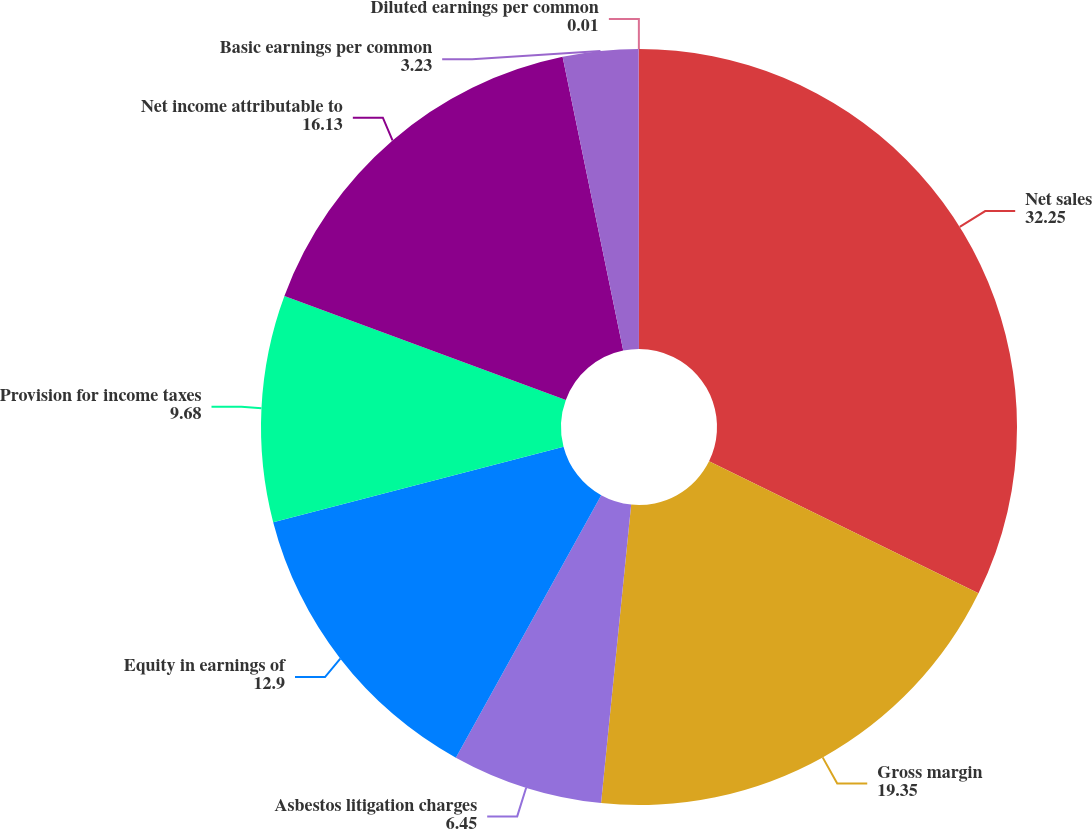Convert chart to OTSL. <chart><loc_0><loc_0><loc_500><loc_500><pie_chart><fcel>Net sales<fcel>Gross margin<fcel>Asbestos litigation charges<fcel>Equity in earnings of<fcel>Provision for income taxes<fcel>Net income attributable to<fcel>Basic earnings per common<fcel>Diluted earnings per common<nl><fcel>32.25%<fcel>19.35%<fcel>6.45%<fcel>12.9%<fcel>9.68%<fcel>16.13%<fcel>3.23%<fcel>0.01%<nl></chart> 